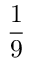Convert formula to latex. <formula><loc_0><loc_0><loc_500><loc_500>\frac { 1 } { 9 }</formula> 